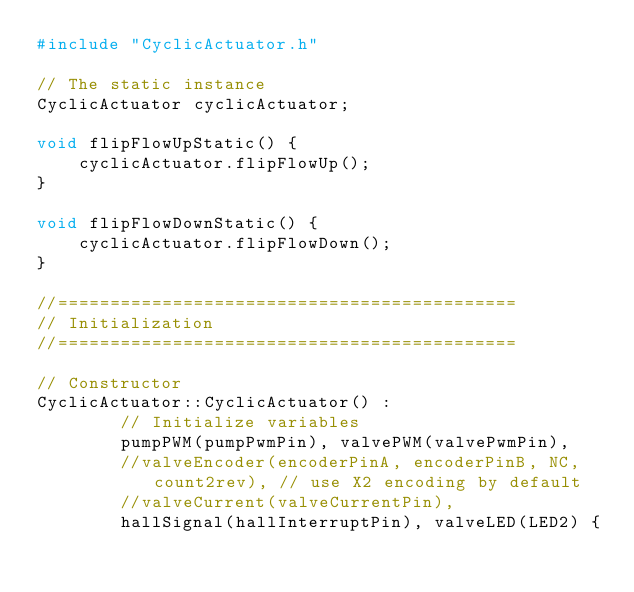<code> <loc_0><loc_0><loc_500><loc_500><_C++_>#include "CyclicActuator.h"

// The static instance
CyclicActuator cyclicActuator;

void flipFlowUpStatic() {
	cyclicActuator.flipFlowUp();
}

void flipFlowDownStatic() {
	cyclicActuator.flipFlowDown();
}

//============================================
// Initialization
//============================================

// Constructor
CyclicActuator::CyclicActuator() :
		// Initialize variables
		pumpPWM(pumpPwmPin), valvePWM(valvePwmPin),
		//valveEncoder(encoderPinA, encoderPinB, NC, count2rev), // use X2 encoding by default
		//valveCurrent(valveCurrentPin),
		hallSignal(hallInterruptPin), valveLED(LED2) {</code> 